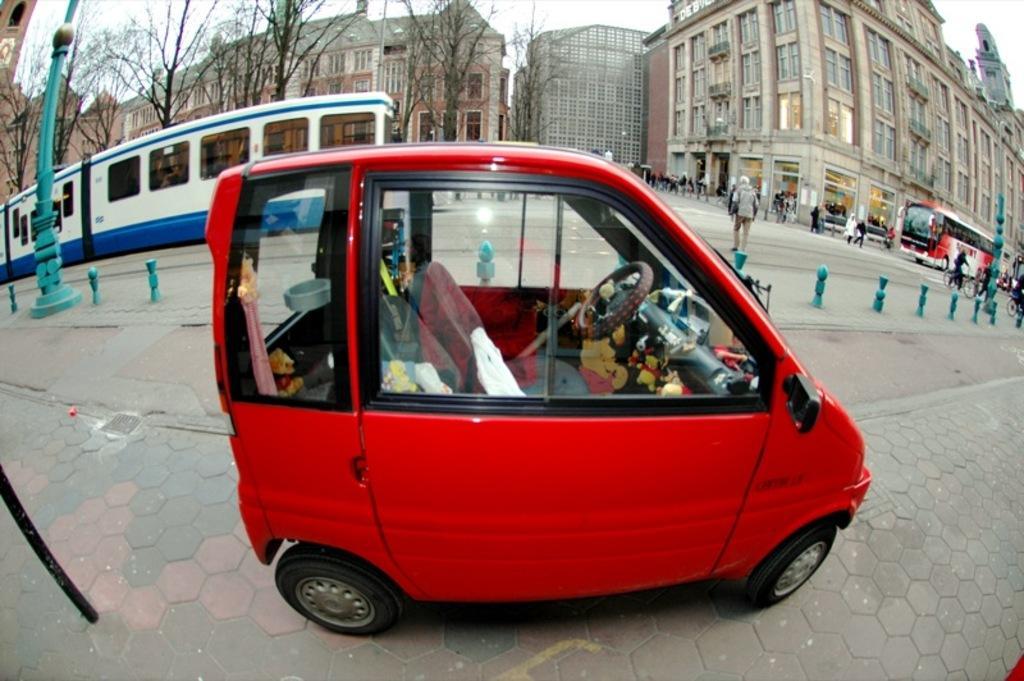In one or two sentences, can you explain what this image depicts? In the picture we can see a road on it, we can see a car which is red in color and behind it, we can see some poles, which are blue in color and behind it, we can see a train, bus and some people are walking on the road and in the background, we can see some trees which are dried and behind it we can see buildings with windows and glasses and behind it we can see a sky. 